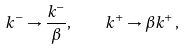Convert formula to latex. <formula><loc_0><loc_0><loc_500><loc_500>k ^ { - } \rightarrow \frac { k ^ { - } } { \beta } , \quad k ^ { + } \rightarrow \beta k ^ { + } \, ,</formula> 